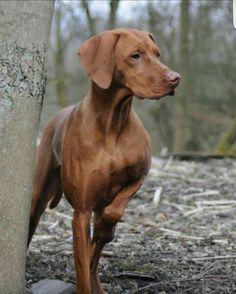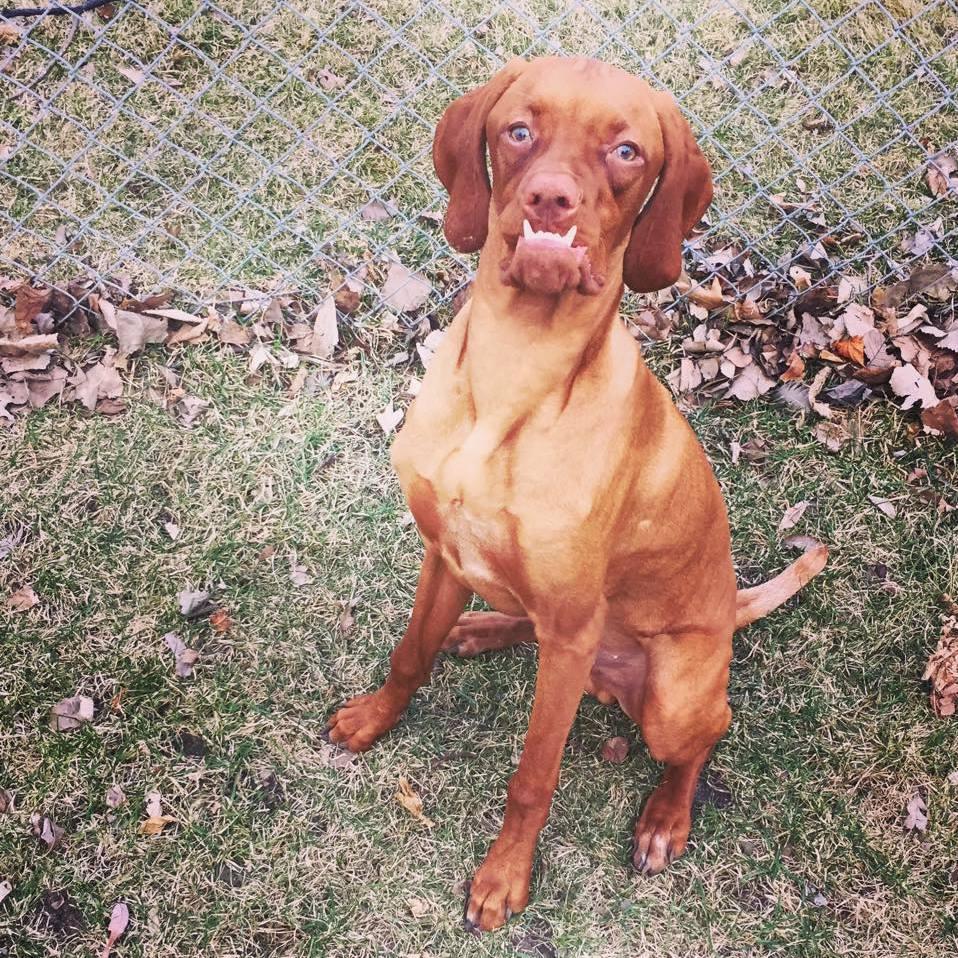The first image is the image on the left, the second image is the image on the right. Examine the images to the left and right. Is the description "One dog is standing." accurate? Answer yes or no. Yes. 